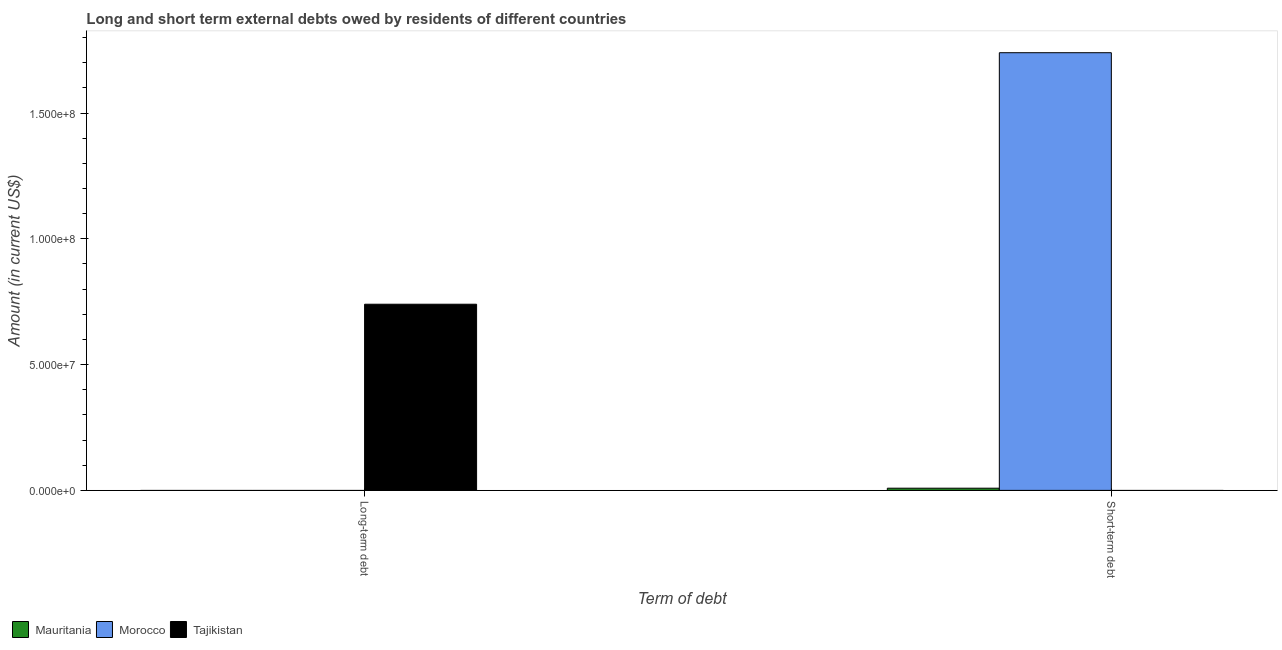How many different coloured bars are there?
Make the answer very short. 3. Are the number of bars per tick equal to the number of legend labels?
Provide a short and direct response. No. How many bars are there on the 2nd tick from the left?
Your answer should be compact. 2. How many bars are there on the 1st tick from the right?
Provide a succinct answer. 2. What is the label of the 1st group of bars from the left?
Your response must be concise. Long-term debt. Across all countries, what is the maximum short-term debts owed by residents?
Provide a short and direct response. 1.74e+08. Across all countries, what is the minimum short-term debts owed by residents?
Make the answer very short. 0. In which country was the short-term debts owed by residents maximum?
Provide a short and direct response. Morocco. What is the total long-term debts owed by residents in the graph?
Provide a short and direct response. 7.40e+07. What is the difference between the short-term debts owed by residents in Mauritania and that in Morocco?
Your answer should be compact. -1.73e+08. What is the difference between the short-term debts owed by residents in Morocco and the long-term debts owed by residents in Tajikistan?
Ensure brevity in your answer.  1.00e+08. What is the average long-term debts owed by residents per country?
Make the answer very short. 2.47e+07. What is the ratio of the short-term debts owed by residents in Morocco to that in Mauritania?
Your answer should be compact. 200. In how many countries, is the short-term debts owed by residents greater than the average short-term debts owed by residents taken over all countries?
Your answer should be compact. 1. How many bars are there?
Your answer should be very brief. 3. How many countries are there in the graph?
Keep it short and to the point. 3. What is the difference between two consecutive major ticks on the Y-axis?
Your answer should be compact. 5.00e+07. Does the graph contain grids?
Offer a very short reply. No. How many legend labels are there?
Provide a succinct answer. 3. What is the title of the graph?
Your answer should be very brief. Long and short term external debts owed by residents of different countries. Does "Ireland" appear as one of the legend labels in the graph?
Provide a short and direct response. No. What is the label or title of the X-axis?
Give a very brief answer. Term of debt. What is the label or title of the Y-axis?
Your response must be concise. Amount (in current US$). What is the Amount (in current US$) of Mauritania in Long-term debt?
Keep it short and to the point. 0. What is the Amount (in current US$) in Morocco in Long-term debt?
Provide a succinct answer. 0. What is the Amount (in current US$) of Tajikistan in Long-term debt?
Your answer should be very brief. 7.40e+07. What is the Amount (in current US$) in Mauritania in Short-term debt?
Make the answer very short. 8.70e+05. What is the Amount (in current US$) in Morocco in Short-term debt?
Ensure brevity in your answer.  1.74e+08. What is the Amount (in current US$) of Tajikistan in Short-term debt?
Offer a very short reply. 0. Across all Term of debt, what is the maximum Amount (in current US$) of Mauritania?
Your response must be concise. 8.70e+05. Across all Term of debt, what is the maximum Amount (in current US$) of Morocco?
Offer a terse response. 1.74e+08. Across all Term of debt, what is the maximum Amount (in current US$) in Tajikistan?
Provide a short and direct response. 7.40e+07. Across all Term of debt, what is the minimum Amount (in current US$) of Mauritania?
Your answer should be compact. 0. Across all Term of debt, what is the minimum Amount (in current US$) of Tajikistan?
Provide a succinct answer. 0. What is the total Amount (in current US$) of Mauritania in the graph?
Your answer should be very brief. 8.70e+05. What is the total Amount (in current US$) in Morocco in the graph?
Provide a succinct answer. 1.74e+08. What is the total Amount (in current US$) in Tajikistan in the graph?
Provide a succinct answer. 7.40e+07. What is the average Amount (in current US$) of Mauritania per Term of debt?
Provide a succinct answer. 4.35e+05. What is the average Amount (in current US$) of Morocco per Term of debt?
Ensure brevity in your answer.  8.70e+07. What is the average Amount (in current US$) of Tajikistan per Term of debt?
Your response must be concise. 3.70e+07. What is the difference between the Amount (in current US$) of Mauritania and Amount (in current US$) of Morocco in Short-term debt?
Make the answer very short. -1.73e+08. What is the difference between the highest and the lowest Amount (in current US$) of Mauritania?
Offer a very short reply. 8.70e+05. What is the difference between the highest and the lowest Amount (in current US$) of Morocco?
Keep it short and to the point. 1.74e+08. What is the difference between the highest and the lowest Amount (in current US$) in Tajikistan?
Your response must be concise. 7.40e+07. 